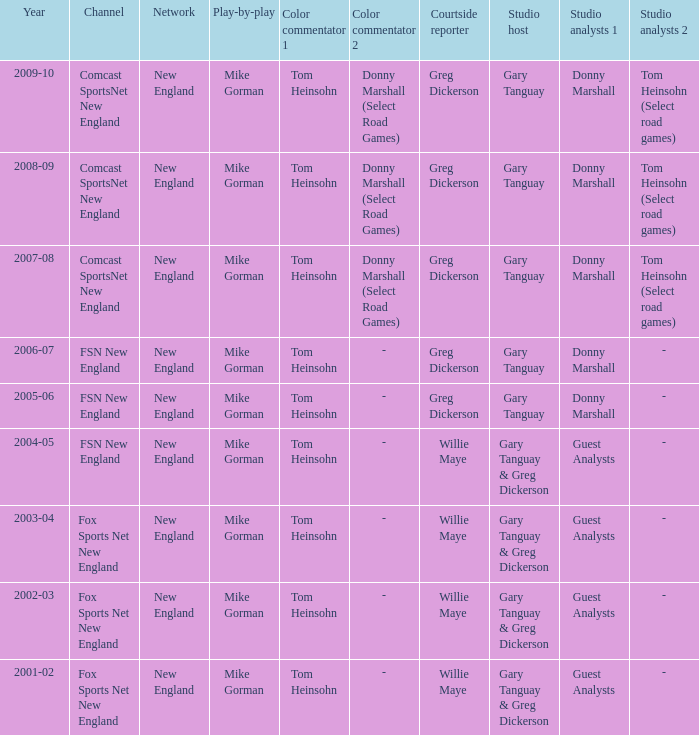Who is the studio host for the year 2006-07? Gary Tanguay. 